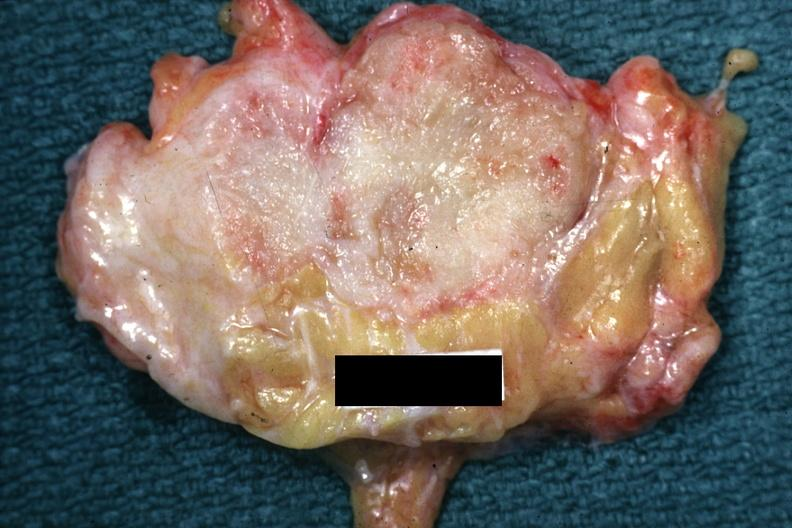s adenocarcinoma present?
Answer the question using a single word or phrase. Yes 